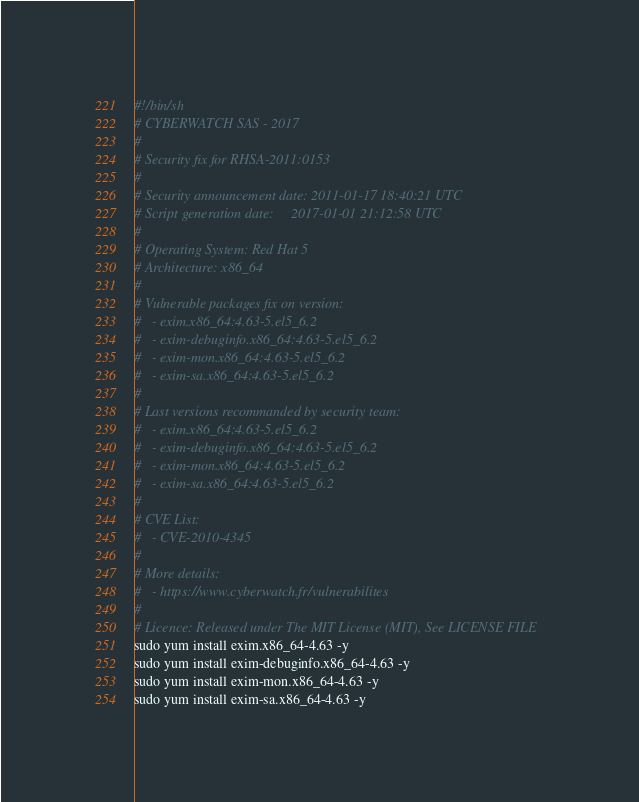<code> <loc_0><loc_0><loc_500><loc_500><_Bash_>#!/bin/sh
# CYBERWATCH SAS - 2017
#
# Security fix for RHSA-2011:0153
#
# Security announcement date: 2011-01-17 18:40:21 UTC
# Script generation date:     2017-01-01 21:12:58 UTC
#
# Operating System: Red Hat 5
# Architecture: x86_64
#
# Vulnerable packages fix on version:
#   - exim.x86_64:4.63-5.el5_6.2
#   - exim-debuginfo.x86_64:4.63-5.el5_6.2
#   - exim-mon.x86_64:4.63-5.el5_6.2
#   - exim-sa.x86_64:4.63-5.el5_6.2
#
# Last versions recommanded by security team:
#   - exim.x86_64:4.63-5.el5_6.2
#   - exim-debuginfo.x86_64:4.63-5.el5_6.2
#   - exim-mon.x86_64:4.63-5.el5_6.2
#   - exim-sa.x86_64:4.63-5.el5_6.2
#
# CVE List:
#   - CVE-2010-4345
#
# More details:
#   - https://www.cyberwatch.fr/vulnerabilites
#
# Licence: Released under The MIT License (MIT), See LICENSE FILE
sudo yum install exim.x86_64-4.63 -y 
sudo yum install exim-debuginfo.x86_64-4.63 -y 
sudo yum install exim-mon.x86_64-4.63 -y 
sudo yum install exim-sa.x86_64-4.63 -y 
</code> 